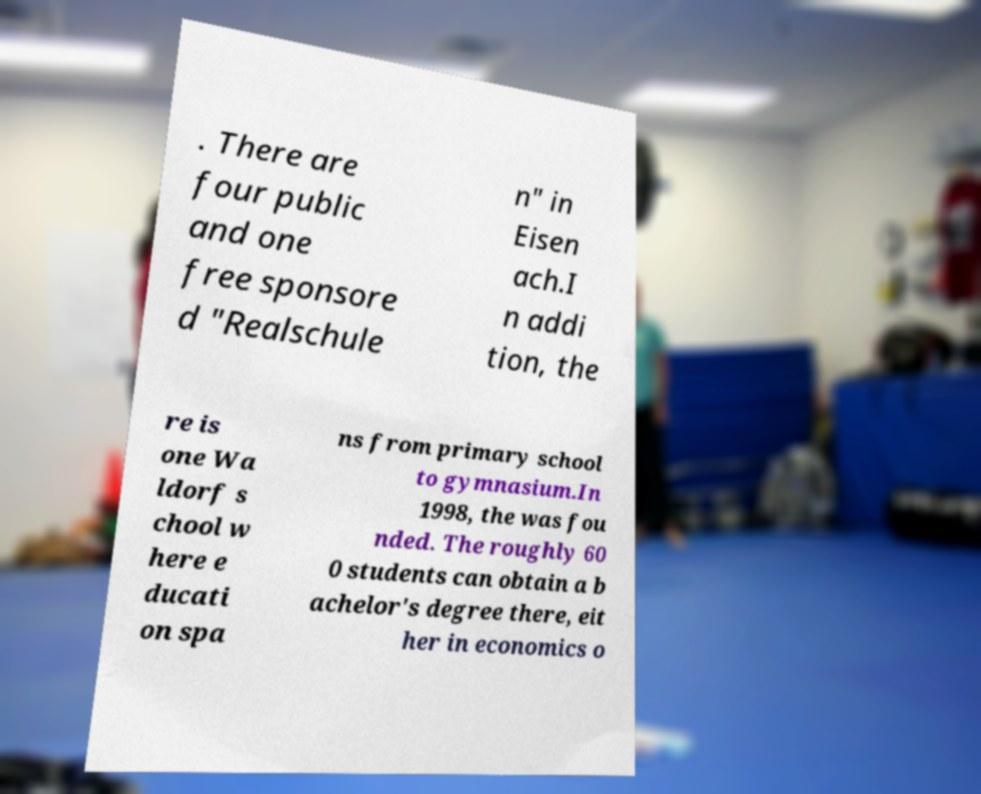Please identify and transcribe the text found in this image. . There are four public and one free sponsore d "Realschule n" in Eisen ach.I n addi tion, the re is one Wa ldorf s chool w here e ducati on spa ns from primary school to gymnasium.In 1998, the was fou nded. The roughly 60 0 students can obtain a b achelor's degree there, eit her in economics o 